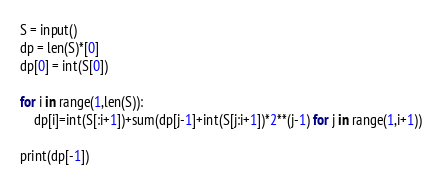Convert code to text. <code><loc_0><loc_0><loc_500><loc_500><_Python_>S = input()
dp = len(S)*[0]
dp[0] = int(S[0])

for i in range(1,len(S)):
    dp[i]=int(S[:i+1])+sum(dp[j-1]+int(S[j:i+1])*2**(j-1) for j in range(1,i+1))
    
print(dp[-1])</code> 